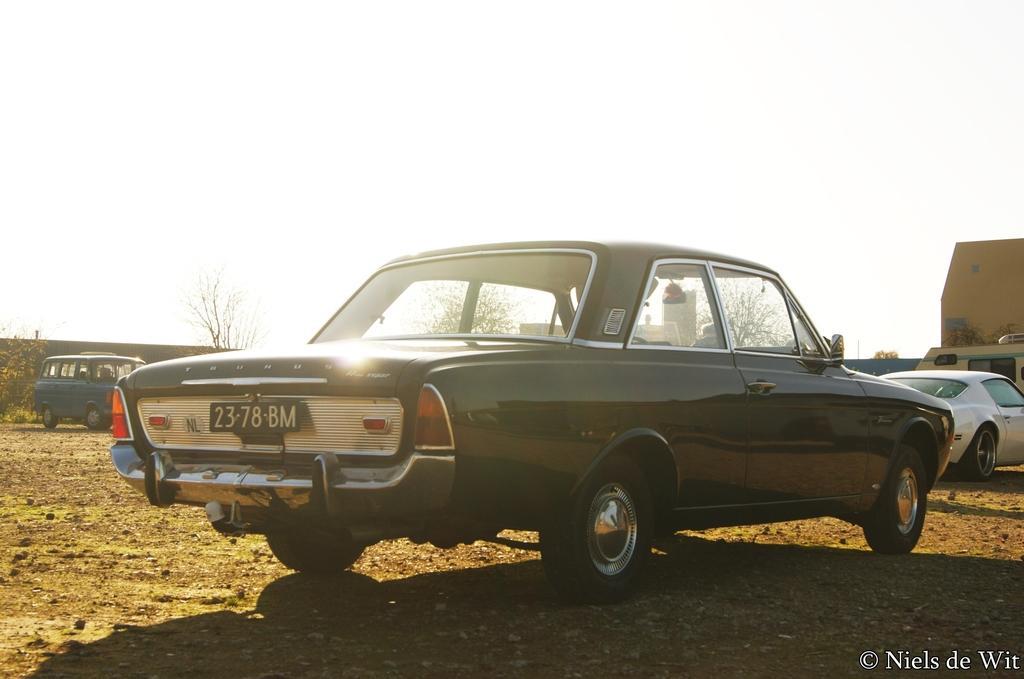Can you describe this image briefly? In this image I can see an open ground and on it I can see few vehicles. In the background I can see few trees, few buildings and I can also see shadows on the ground. On the bottom right side of this image I can see a watermark. 